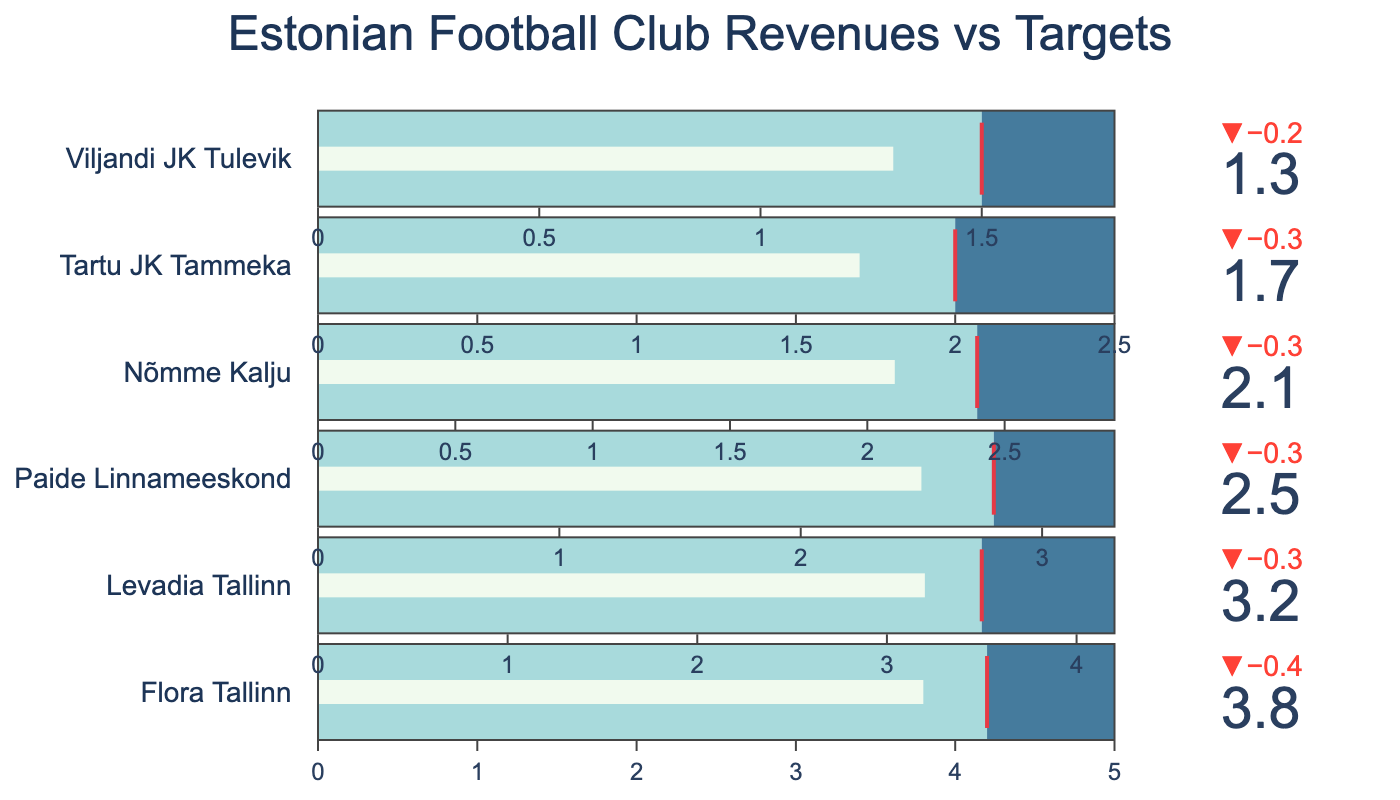Which club has the highest actual revenue? To determine the club with the highest actual revenue, refer to the bullet charts. Flora Tallinn's bullet chart indicates an actual revenue of 3.8, which is the highest among the clubs listed.
Answer: Flora Tallinn How much more is the maximum expected revenue than the actual revenue for Nõmme Kalju? To find the difference between Nõmme Kalju's maximum expected revenue and its actual revenue, subtract the actual revenue from the maximum expected revenue: 2.9 - 2.1 = 0.8.
Answer: 0.8 Which club came closest to meeting its target revenue? To find the club closest to meeting its target revenue, compare the gaps between actual revenues and target revenues. Flora Tallinn has an actual revenue of 3.8 and a target revenue of 4.2, which gives a difference of 0.4. Other clubs have larger differences, so Flora Tallinn came closest.
Answer: Flora Tallinn What is the average target revenue of all clubs? To find the average target revenue, sum all the target revenues and divide by the number of clubs: (4.2 + 3.5 + 2.8 + 2.4 + 2.0 + 1.5) / 6 = 16.4 / 6 = 2.733.
Answer: 2.733 Which club has the largest positive delta between actual and target revenues? Analyze the deltas (actual revenue minus target revenue) for each club. Flora Tallinn: (3.8 - 4.2 = -0.4), Levadia Tallinn: (3.2 - 3.5 = -0.3), Paide Linnameeskond: (2.5 - 2.8 = -0.3), Nõmme Kalju: (2.1 - 2.4 = -0.3), Tartu JK Tammeka: (1.7 - 2.0 = -0.3), Viljandi JK Tulevik: (1.3 - 1.5 = -0.2). The smallest negative delta (closest to zero) is for Viljandi JK Tulevik.
Answer: Viljandi JK Tulevik What is the combined actual revenue of the three clubs with the lowest actual revenues? Identify the three clubs with the lowest actual revenues: Viljandi JK Tulevik (1.3), Tartu JK Tammeka (1.7), and Nõmme Kalju (2.1). Their combined actual revenue is 1.3 + 1.7 + 2.1 = 5.1.
Answer: 5.1 Which club exceeds half of its maximum expected revenue? Check which clubs have an actual revenue greater than half of their maximum expected revenue. Flora Tallinn's 3.8 is greater than half of 5.0 (2.5), so it exceeds half of its maximum expected revenue. Other clubs do not meet this criterion.
Answer: Flora Tallinn 